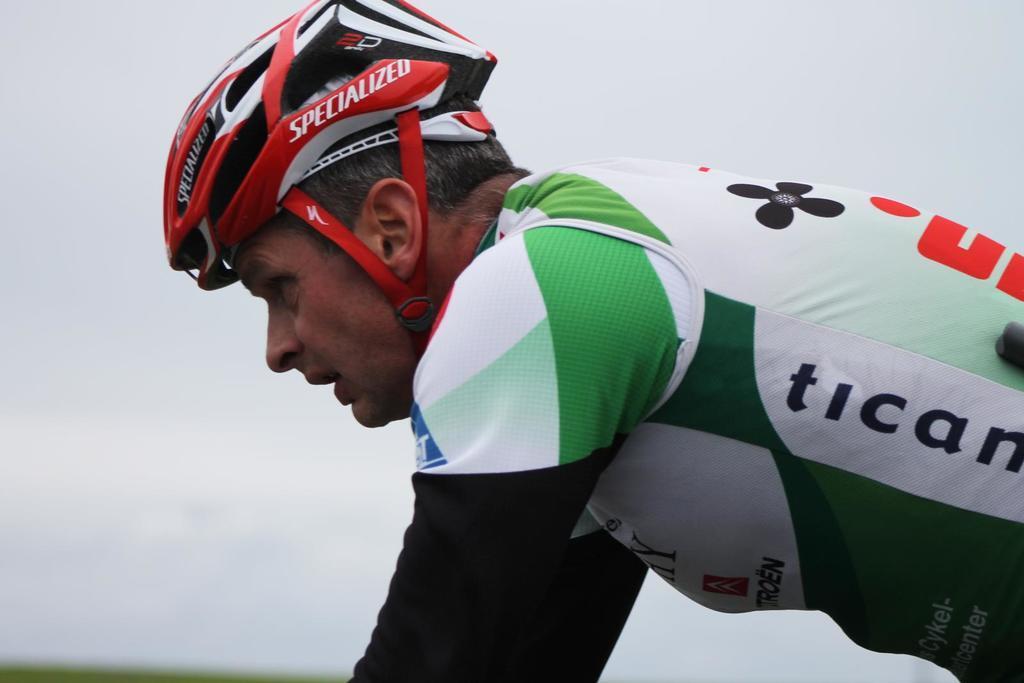In one or two sentences, can you explain what this image depicts? In this image there is a person with a helmet , and there is white color background. 